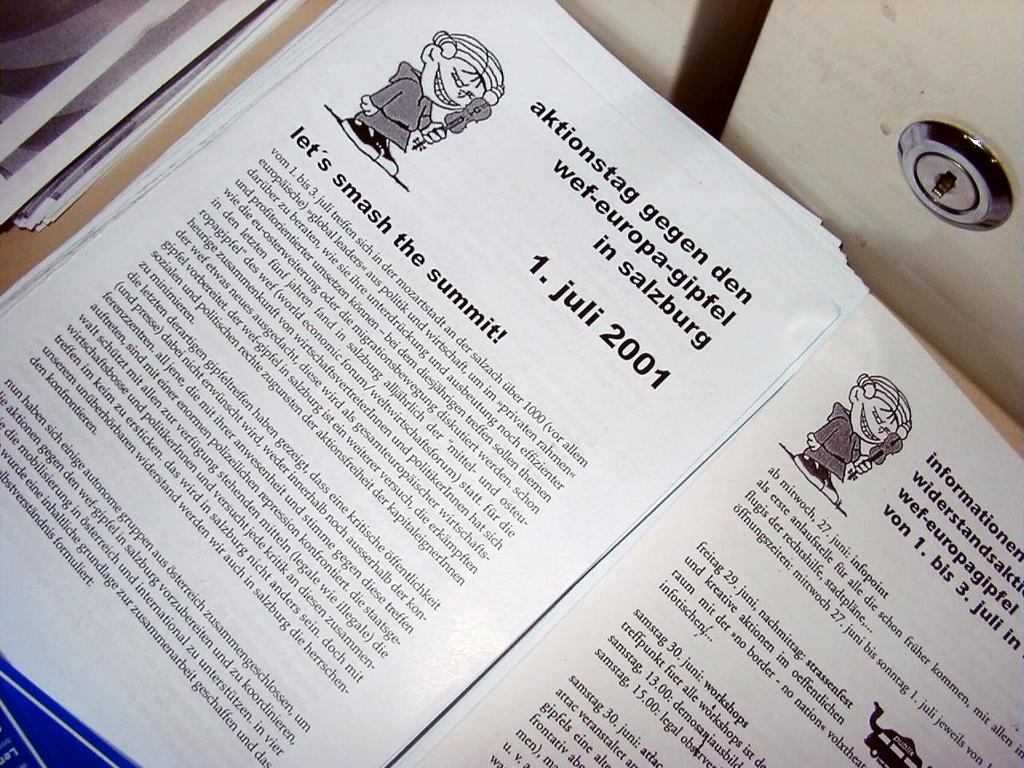<image>
Share a concise interpretation of the image provided. A paper contains an article that is titled "let's smash the summit!" 